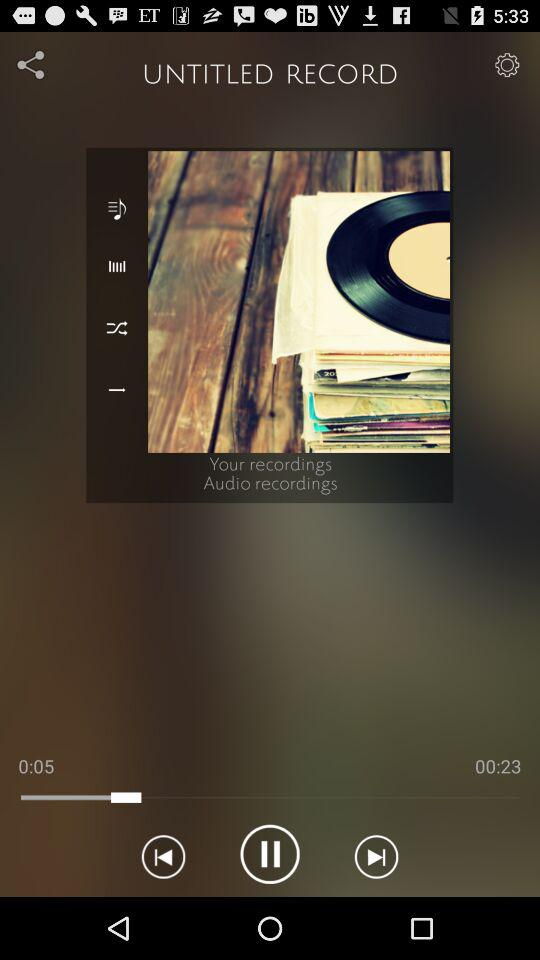What is the total duration of the audio? The total duration of the audio is 23 seconds. 